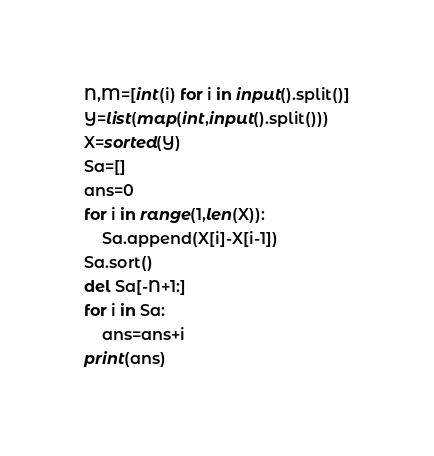Convert code to text. <code><loc_0><loc_0><loc_500><loc_500><_Python_>N,M=[int(i) for i in input().split()]
Y=list(map(int,input().split()))
X=sorted(Y)
Sa=[]
ans=0
for i in range(1,len(X)):
    Sa.append(X[i]-X[i-1])
Sa.sort()
del Sa[-N+1:]
for i in Sa:
    ans=ans+i
print(ans)</code> 